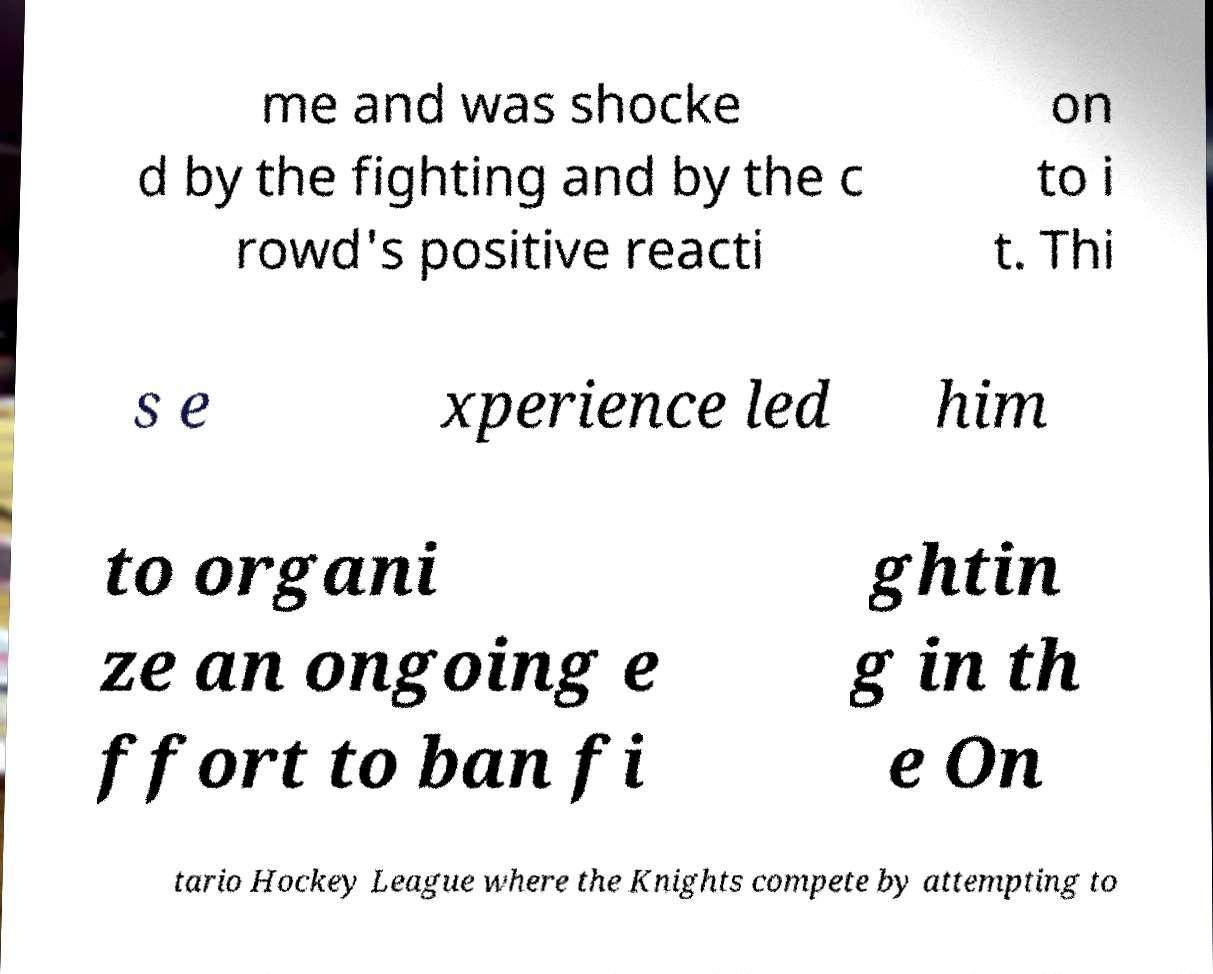Can you read and provide the text displayed in the image?This photo seems to have some interesting text. Can you extract and type it out for me? me and was shocke d by the fighting and by the c rowd's positive reacti on to i t. Thi s e xperience led him to organi ze an ongoing e ffort to ban fi ghtin g in th e On tario Hockey League where the Knights compete by attempting to 